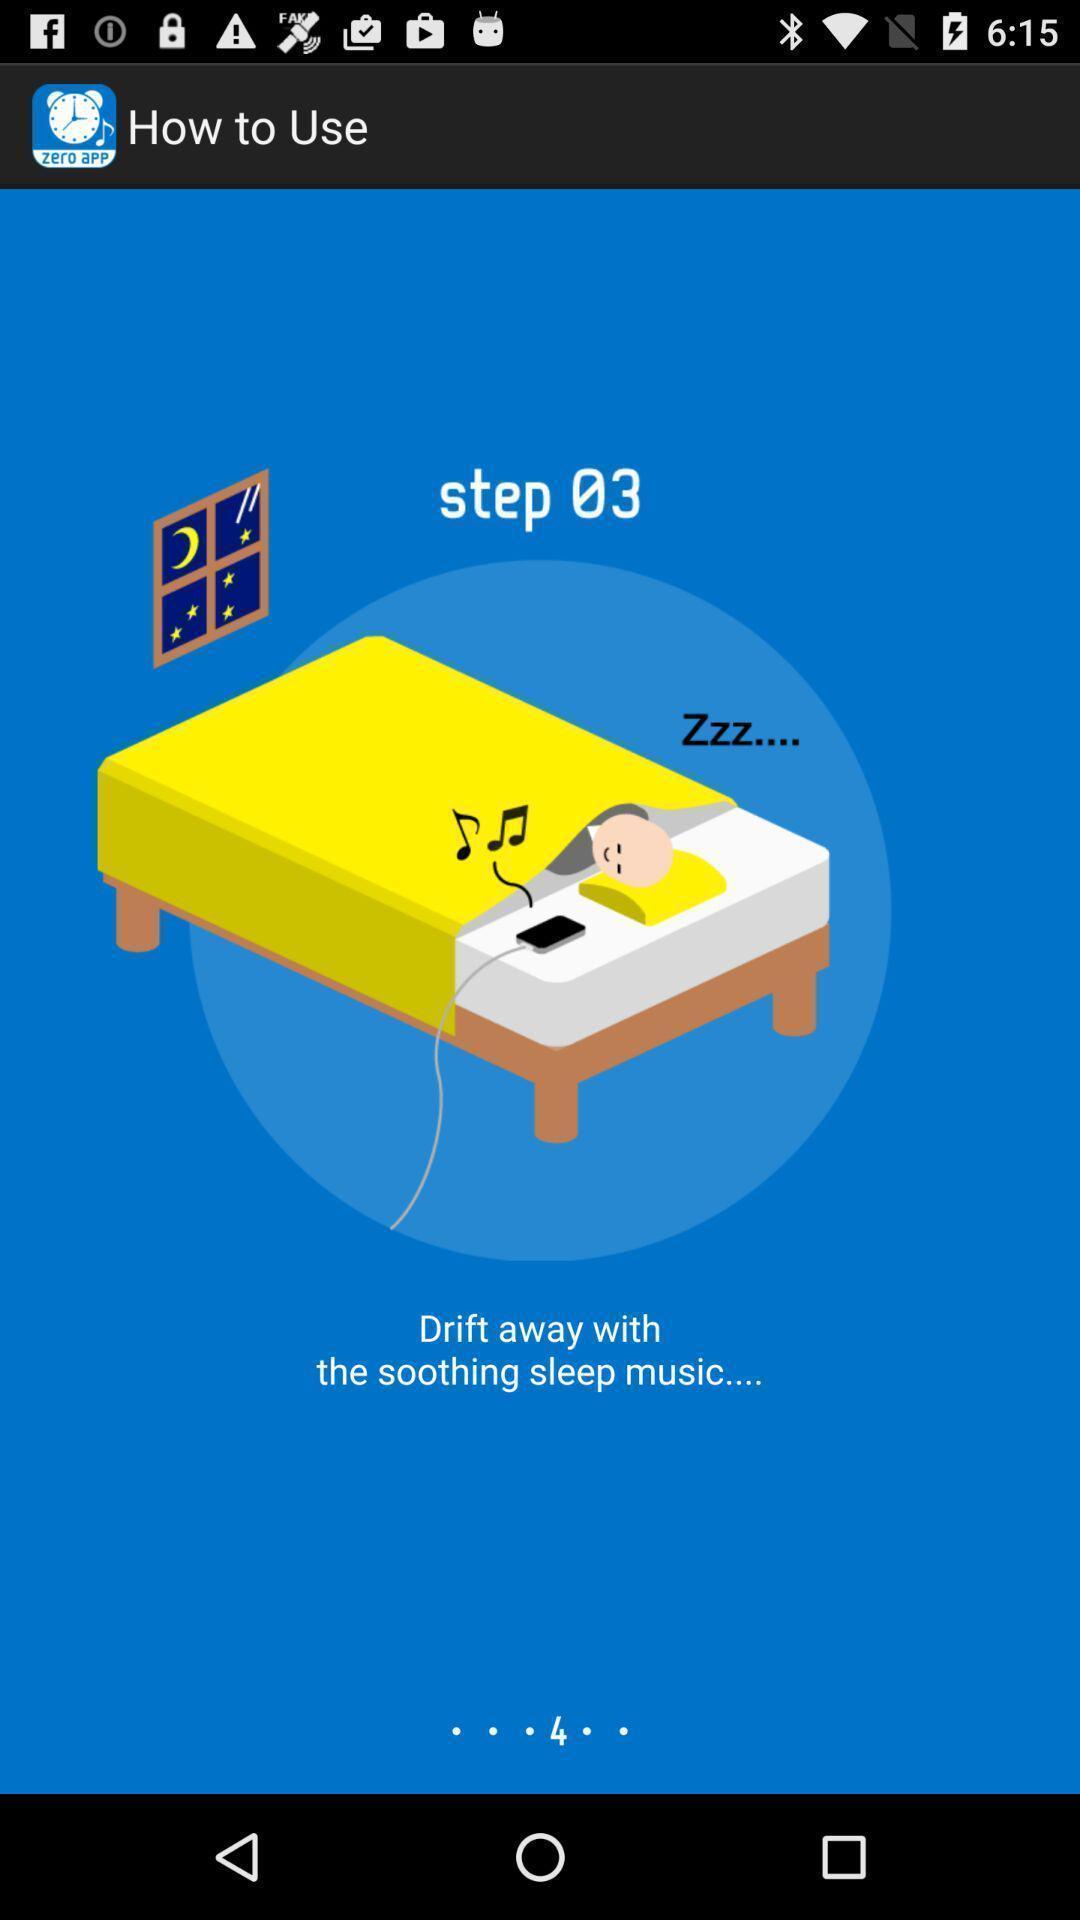What is the overall content of this screenshot? Steps to use a alarm app. 